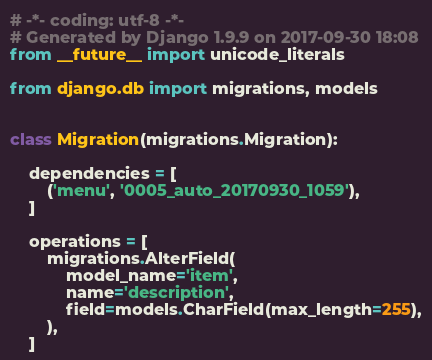Convert code to text. <code><loc_0><loc_0><loc_500><loc_500><_Python_># -*- coding: utf-8 -*-
# Generated by Django 1.9.9 on 2017-09-30 18:08
from __future__ import unicode_literals

from django.db import migrations, models


class Migration(migrations.Migration):

    dependencies = [
        ('menu', '0005_auto_20170930_1059'),
    ]

    operations = [
        migrations.AlterField(
            model_name='item',
            name='description',
            field=models.CharField(max_length=255),
        ),
    ]
</code> 